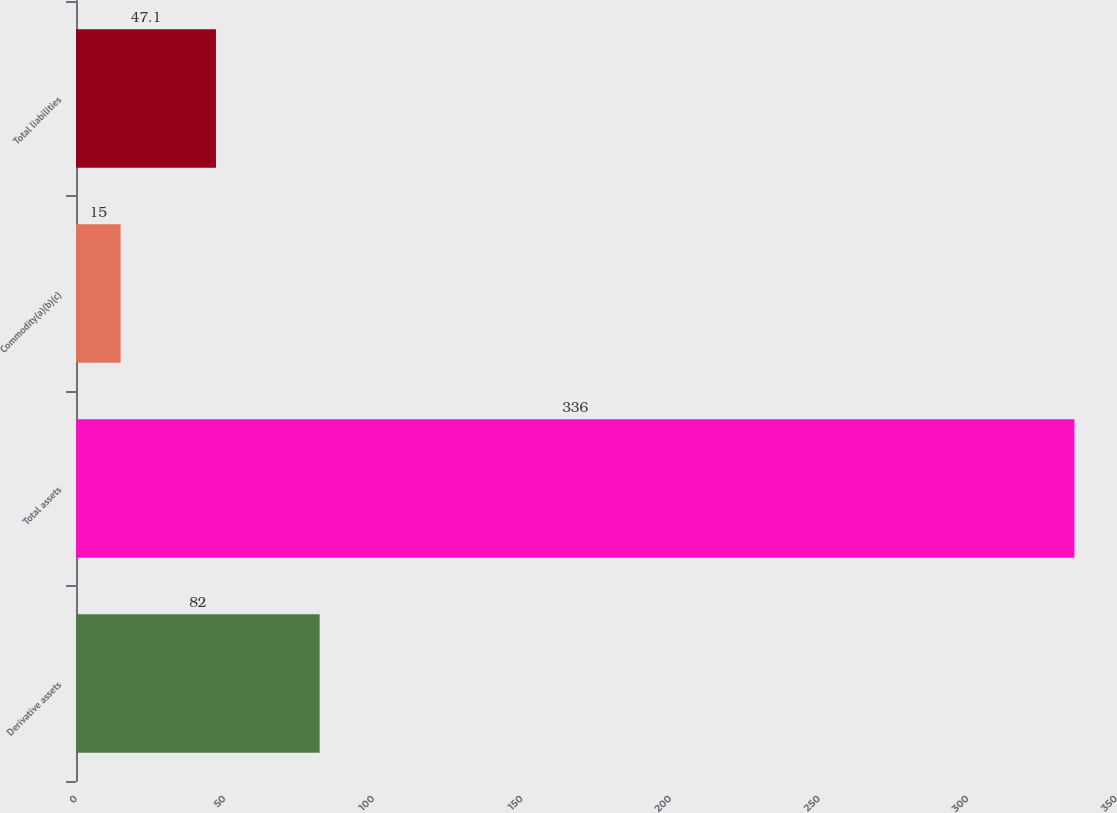Convert chart to OTSL. <chart><loc_0><loc_0><loc_500><loc_500><bar_chart><fcel>Derivative assets<fcel>Total assets<fcel>Commodity(a)(b)(c)<fcel>Total liabilities<nl><fcel>82<fcel>336<fcel>15<fcel>47.1<nl></chart> 